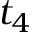Convert formula to latex. <formula><loc_0><loc_0><loc_500><loc_500>t _ { 4 }</formula> 